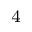Convert formula to latex. <formula><loc_0><loc_0><loc_500><loc_500>^ { 4 }</formula> 